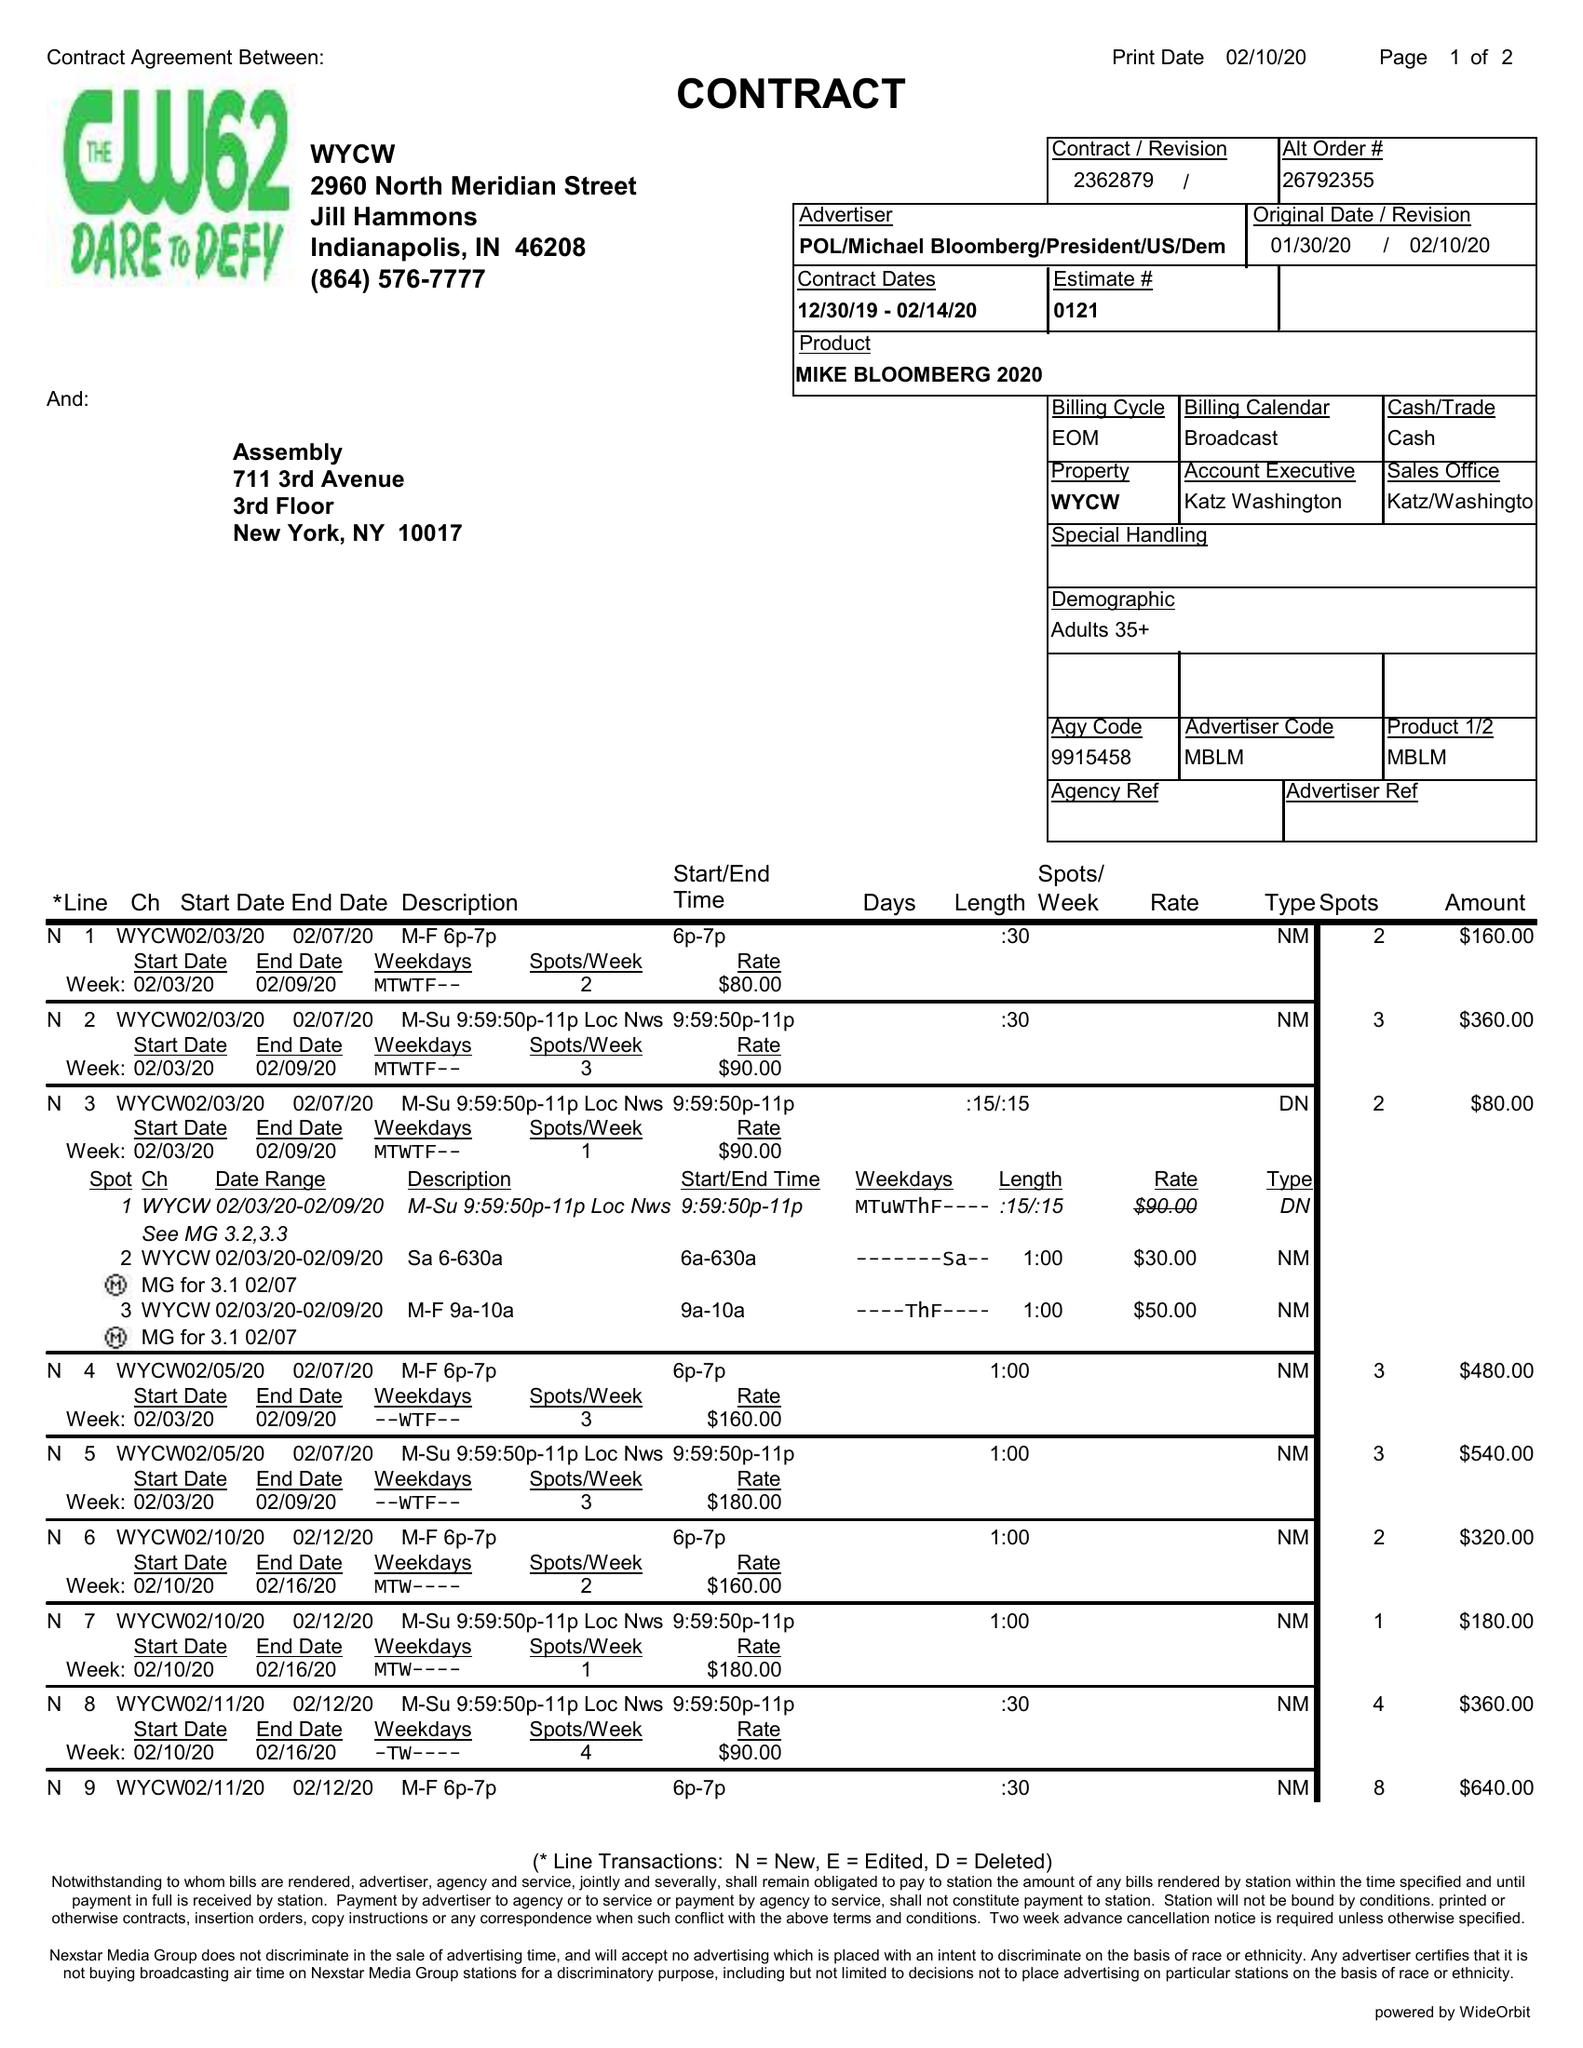What is the value for the gross_amount?
Answer the question using a single word or phrase. 3120.00 